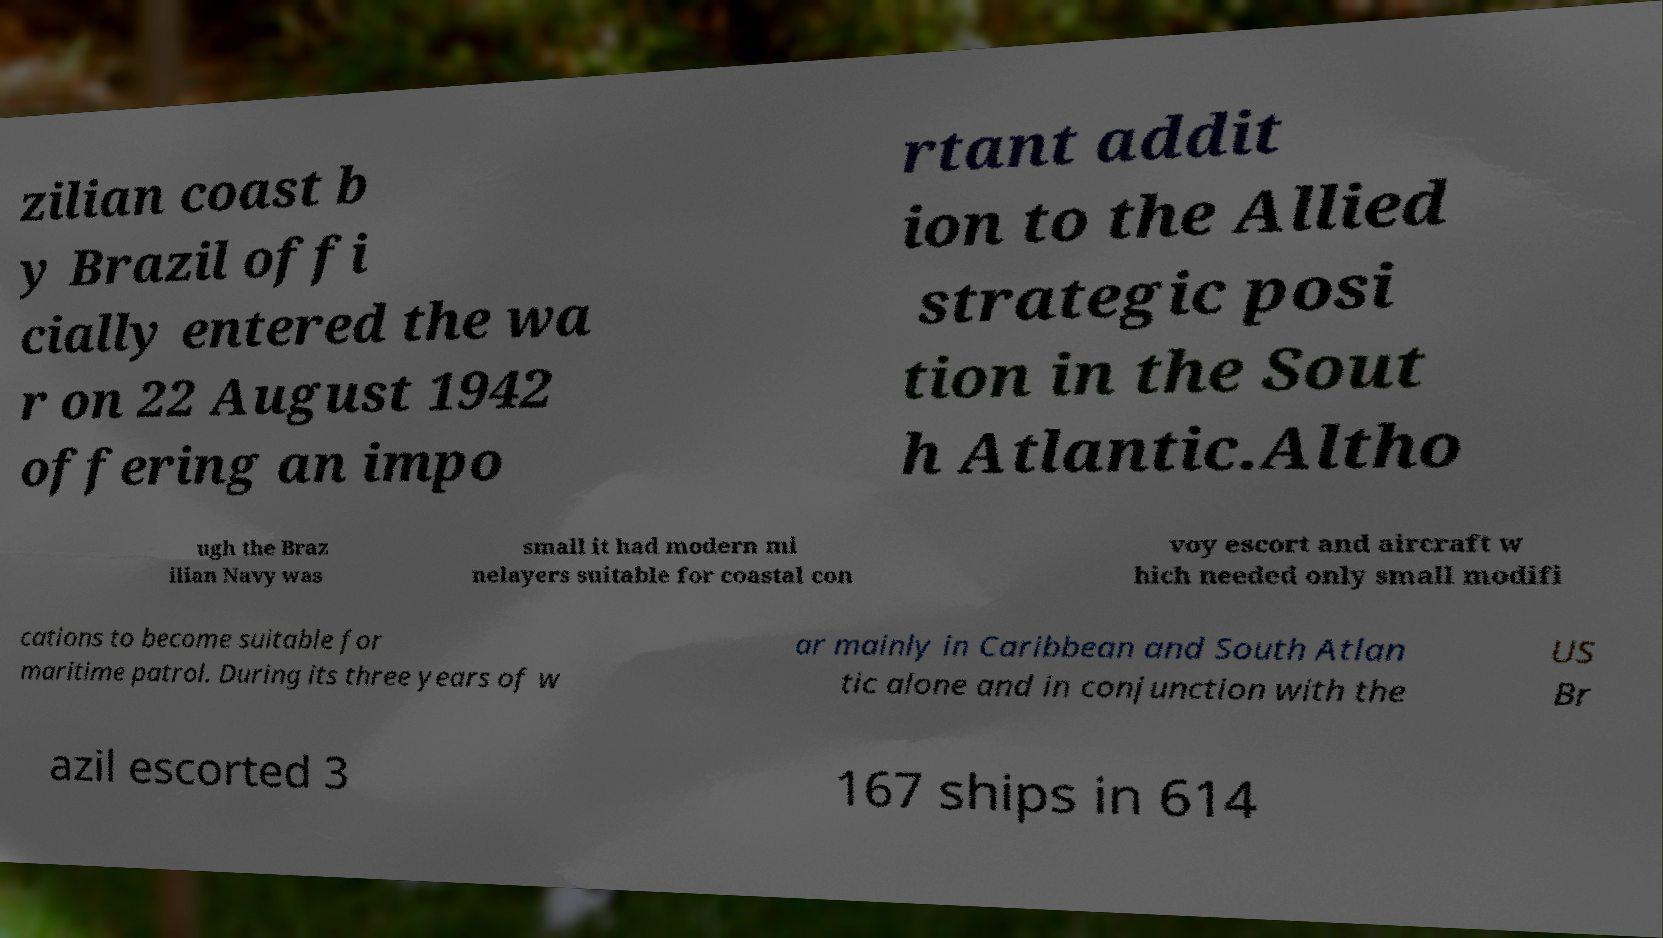Please identify and transcribe the text found in this image. zilian coast b y Brazil offi cially entered the wa r on 22 August 1942 offering an impo rtant addit ion to the Allied strategic posi tion in the Sout h Atlantic.Altho ugh the Braz ilian Navy was small it had modern mi nelayers suitable for coastal con voy escort and aircraft w hich needed only small modifi cations to become suitable for maritime patrol. During its three years of w ar mainly in Caribbean and South Atlan tic alone and in conjunction with the US Br azil escorted 3 167 ships in 614 